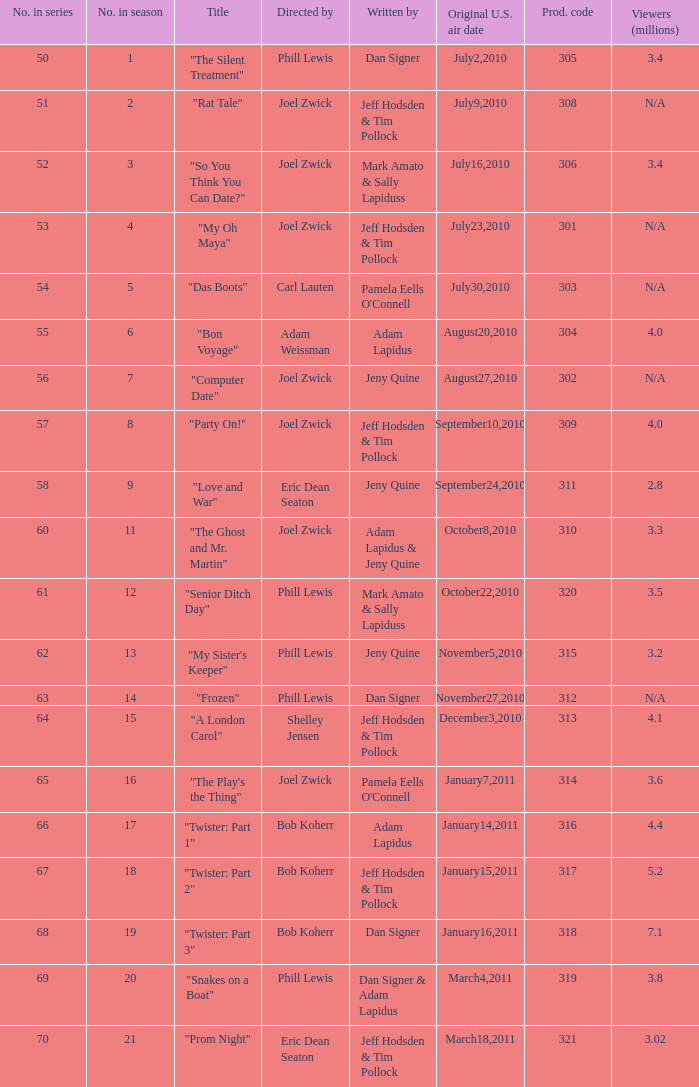In which episode number did the title "my oh maya" appear? 4.0. 